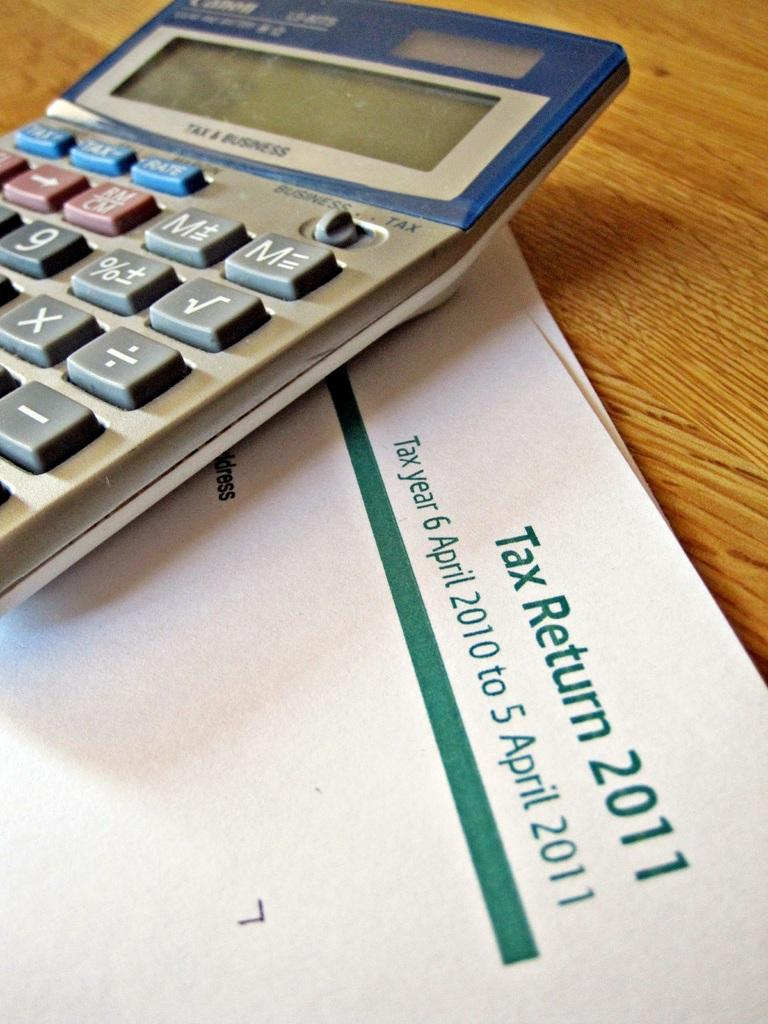<image>
Share a concise interpretation of the image provided. A calculator sits on top of a tax return from 2011. 